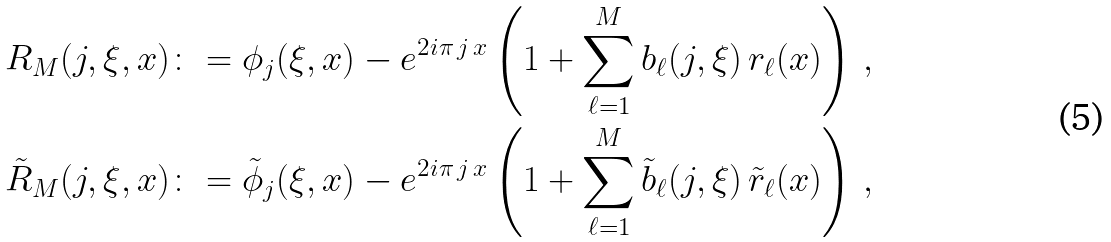<formula> <loc_0><loc_0><loc_500><loc_500>R _ { M } ( j , \xi , x ) & \colon = \phi _ { j } ( \xi , x ) - e ^ { 2 i \pi \, j \, x } \left ( 1 + \sum _ { \ell = 1 } ^ { M } b _ { \ell } ( j , \xi ) \, r _ { \ell } ( x ) \right ) \, , \\ \tilde { R } _ { M } ( j , \xi , x ) & \colon = \tilde { \phi } _ { j } ( \xi , x ) - e ^ { 2 i \pi \, j \, x } \left ( 1 + \sum _ { \ell = 1 } ^ { M } \tilde { b } _ { \ell } ( j , \xi ) \, \tilde { r } _ { \ell } ( x ) \right ) \, ,</formula> 